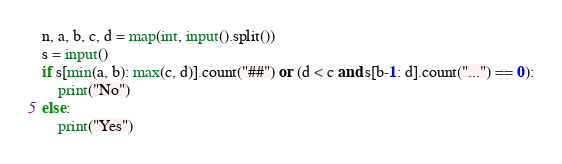<code> <loc_0><loc_0><loc_500><loc_500><_Python_>n, a, b, c, d = map(int, input().split())
s = input()
if s[min(a, b): max(c, d)].count("##") or (d < c and s[b-1: d].count("...") == 0):
    print("No")
else:
    print("Yes")
</code> 